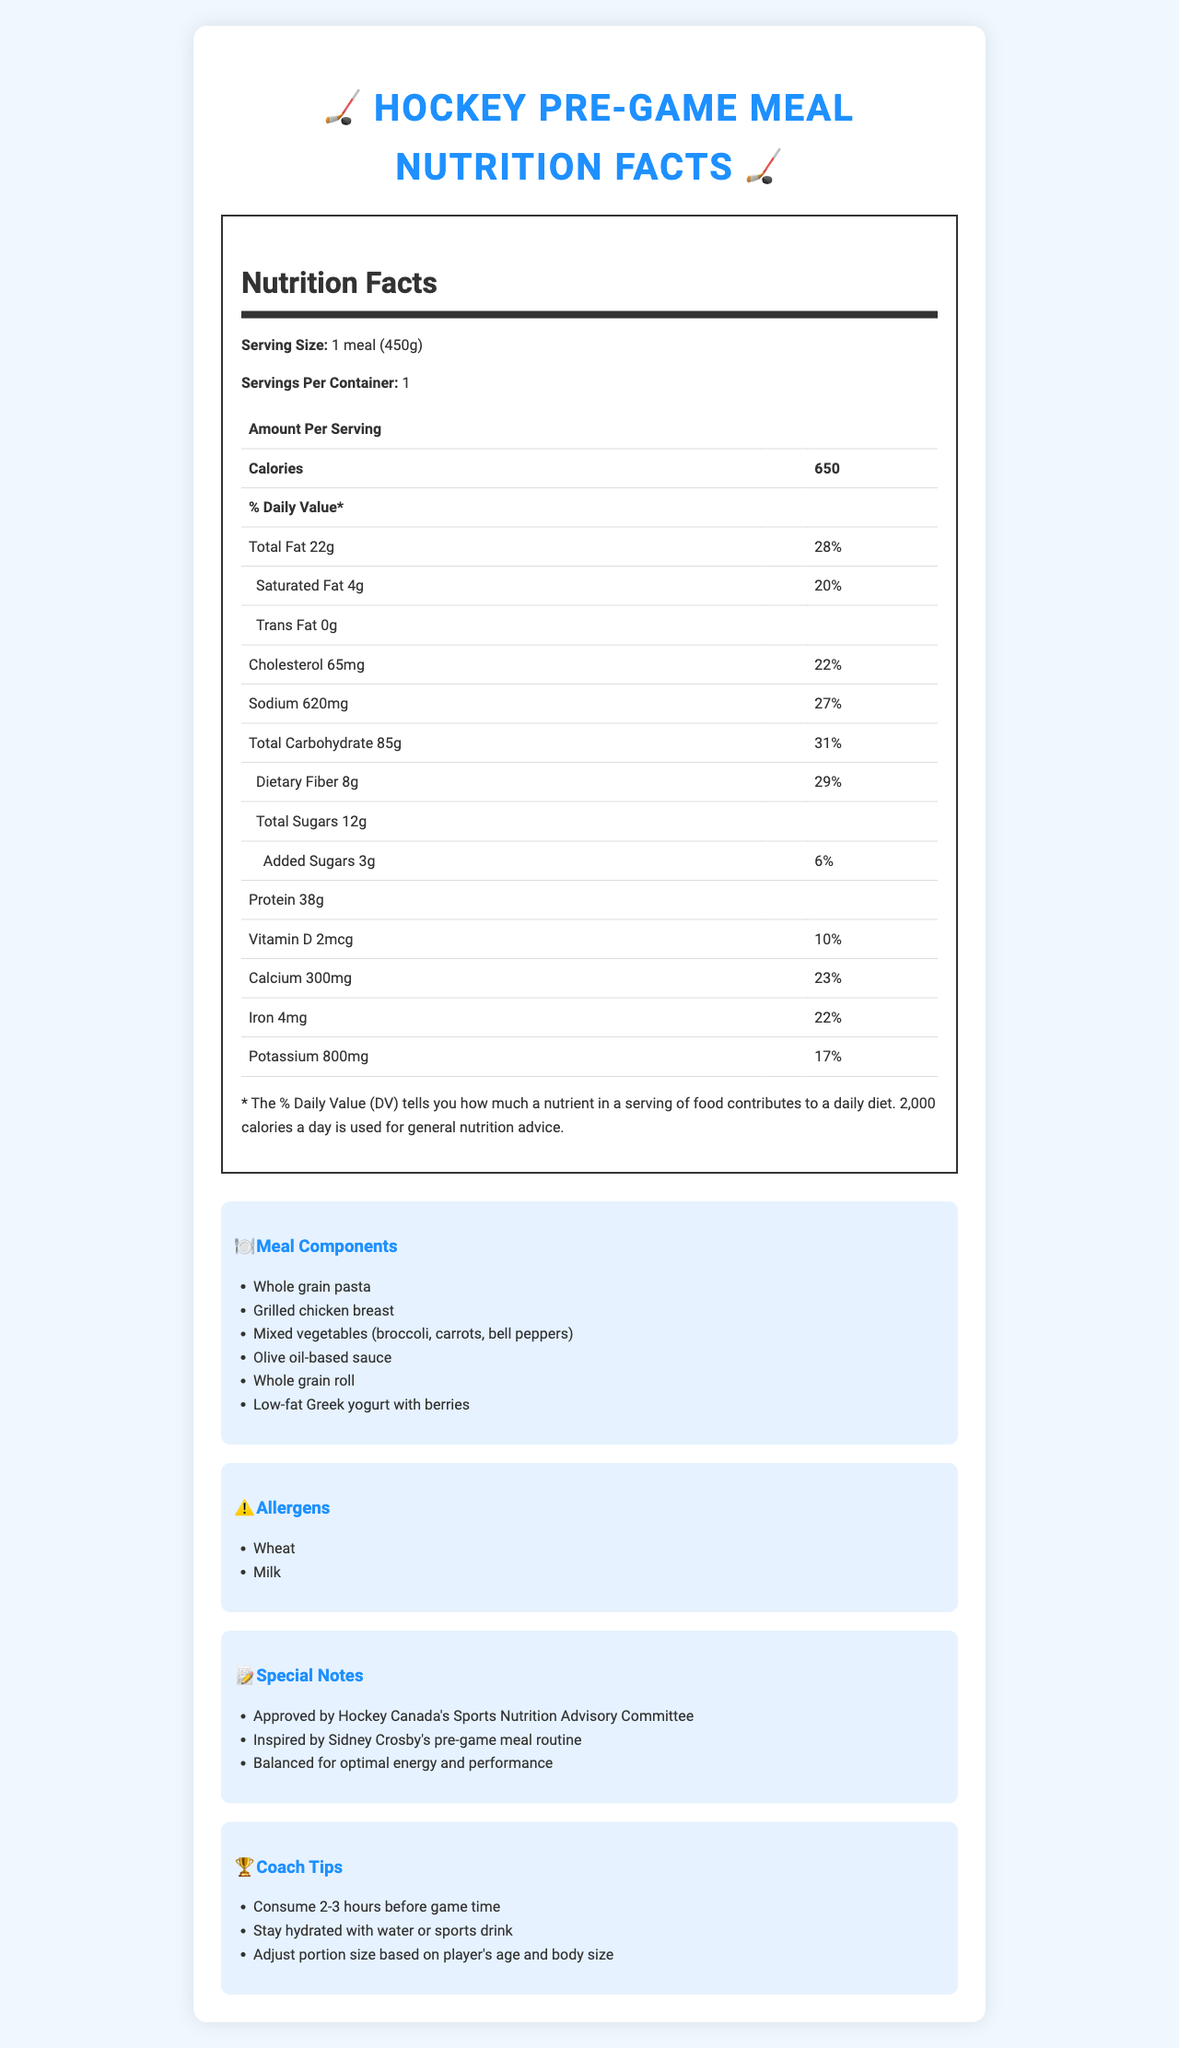what is the serving size of the meal? The serving size is clearly listed as "1 meal (450g)" in the document.
Answer: 1 meal (450g) how many calories are in one serving of this meal? The document states the amount of calories per serving as 650.
Answer: 650 calories list two main sources of protein in the meal components. These components are specifically mentioned in the "Meal Components" section.
Answer: Grilled chicken breast, Low-fat Greek yogurt what percentage of the daily value of dietary fiber does this meal provide? The document lists the daily value of dietary fiber as 29%.
Answer: 29% name one special note about this pre-game meal. This is one of the special notes provided in the document.
Answer: Approved by Hockey Canada's Sports Nutrition Advisory Committee how long before game time should this meal be consumed? A. 1-2 hours B. 2-3 hours C. 3-4 hours The coach tips specify that the meal should be consumed 2-3 hours before game time.
Answer: B which of the following components is **not** included in the meal? A. Quinoa B. Whole grain pasta C. Mixed vegetables Quinoa is not listed in the meal components, whereas whole grain pasta and mixed vegetables are.
Answer: A does the meal contain any added sugars? The document lists "Added Sugars: 3g" indicating the presence of added sugars.
Answer: Yes is this meal designed for optimal energy and performance? One of the special notes says the meal is balanced for optimal energy and performance.
Answer: Yes briefly summarize the main idea of this document. The document includes nutritional facts, essential meal ingredients, potential allergens, notes on approval and inspiration, and tips for consumption and hydration.
Answer: This document provides detailed nutritional information, meal components, allergens, special notes, and coach tips for a high-energy pre-game meal designed for young hockey players. what is the main ingredient in the sauce? The document only refers to an "Olive oil-based sauce" and does not specify the main ingredient.
Answer: Not mentioned what is the total carbohydrate content of the meal? The document lists the total carbohydrate content per serving as 85g.
Answer: 85g how much vitamin D does this meal provide? The vitamin D content is listed as 2mcg in the nutritional facts table.
Answer: 2mcg what allergens are present in this meal? The allergens section specifically lists wheat and milk.
Answer: Wheat, Milk what is the daily value percentage of calcium provided by this meal? The document indicates that the meal provides 23% of the daily value for calcium.
Answer: 23% 